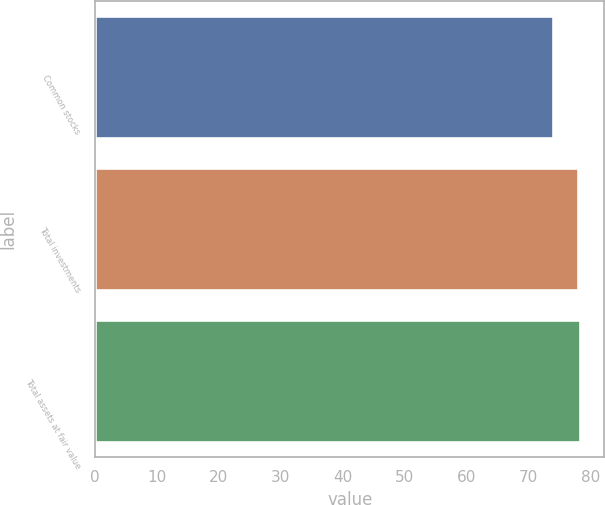Convert chart. <chart><loc_0><loc_0><loc_500><loc_500><bar_chart><fcel>Common stocks<fcel>Total investments<fcel>Total assets at fair value<nl><fcel>74<fcel>78<fcel>78.4<nl></chart> 